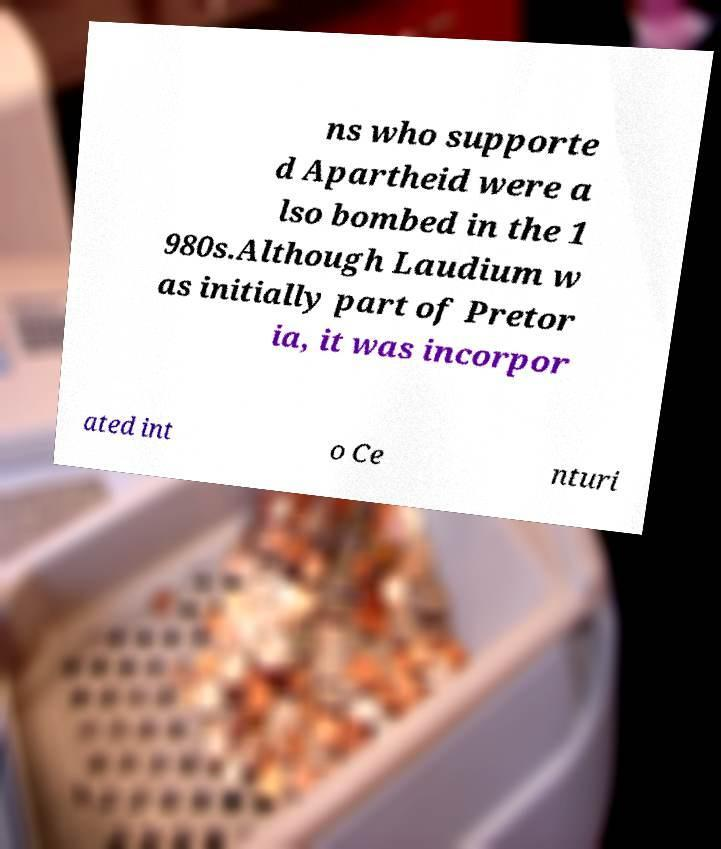Could you extract and type out the text from this image? ns who supporte d Apartheid were a lso bombed in the 1 980s.Although Laudium w as initially part of Pretor ia, it was incorpor ated int o Ce nturi 